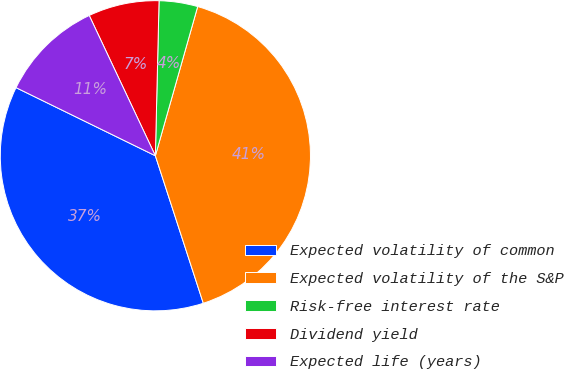Convert chart to OTSL. <chart><loc_0><loc_0><loc_500><loc_500><pie_chart><fcel>Expected volatility of common<fcel>Expected volatility of the S&P<fcel>Risk-free interest rate<fcel>Dividend yield<fcel>Expected life (years)<nl><fcel>37.24%<fcel>40.6%<fcel>4.02%<fcel>7.39%<fcel>10.75%<nl></chart> 